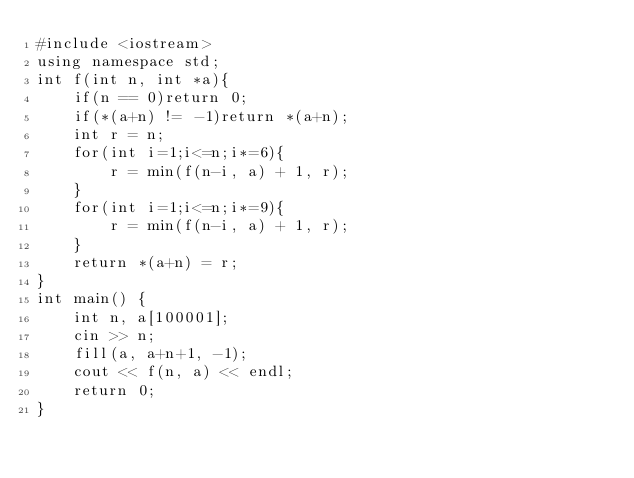Convert code to text. <code><loc_0><loc_0><loc_500><loc_500><_C++_>#include <iostream>
using namespace std;
int f(int n, int *a){
    if(n == 0)return 0;
    if(*(a+n) != -1)return *(a+n);
    int r = n;
    for(int i=1;i<=n;i*=6){
        r = min(f(n-i, a) + 1, r);
    }
    for(int i=1;i<=n;i*=9){
        r = min(f(n-i, a) + 1, r);
    }
    return *(a+n) = r;
}
int main() {
    int n, a[100001];
    cin >> n;
    fill(a, a+n+1, -1);
    cout << f(n, a) << endl;
	return 0;
}</code> 